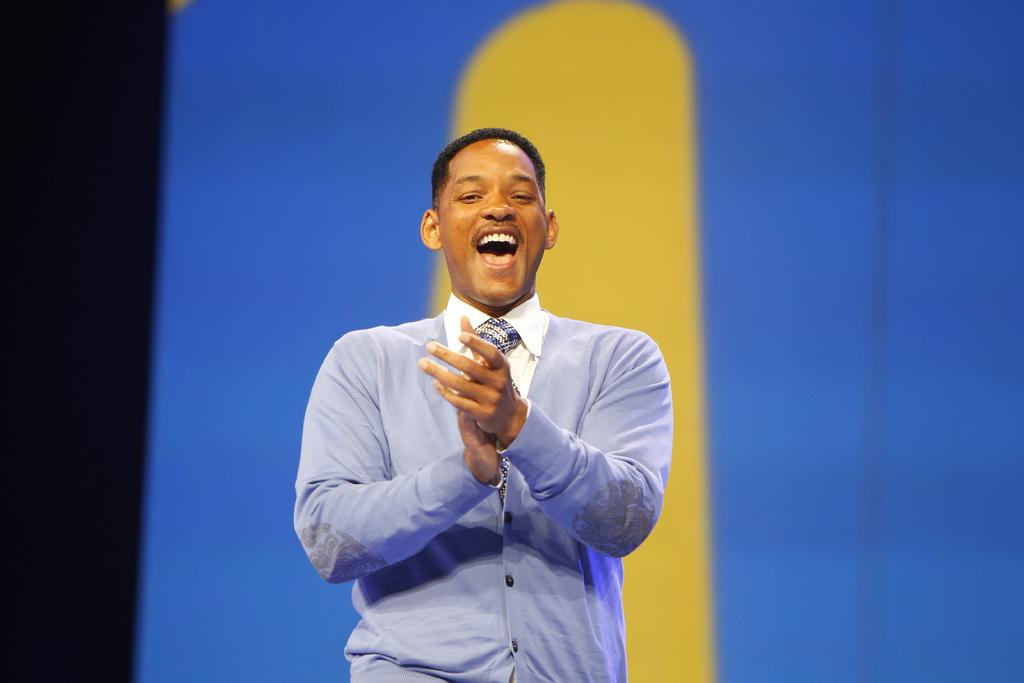Who is in the image? There is a person in the image. What is the person wearing on their upper body? The person is wearing a blue jacket, a shirt, and a tie. What is the person doing in the image? The person is standing and smiling. What colors can be seen in the background of the image? The background of the image has black, blue, and yellow colors. What type of drink is the person holding in the image? There is no drink visible in the image; the person is not holding anything. 